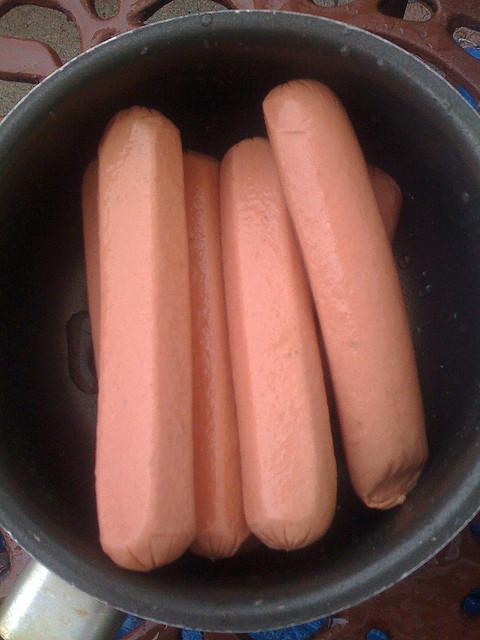What is bad about this food? sodium 